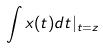<formula> <loc_0><loc_0><loc_500><loc_500>\int x ( t ) d t | _ { t = z }</formula> 